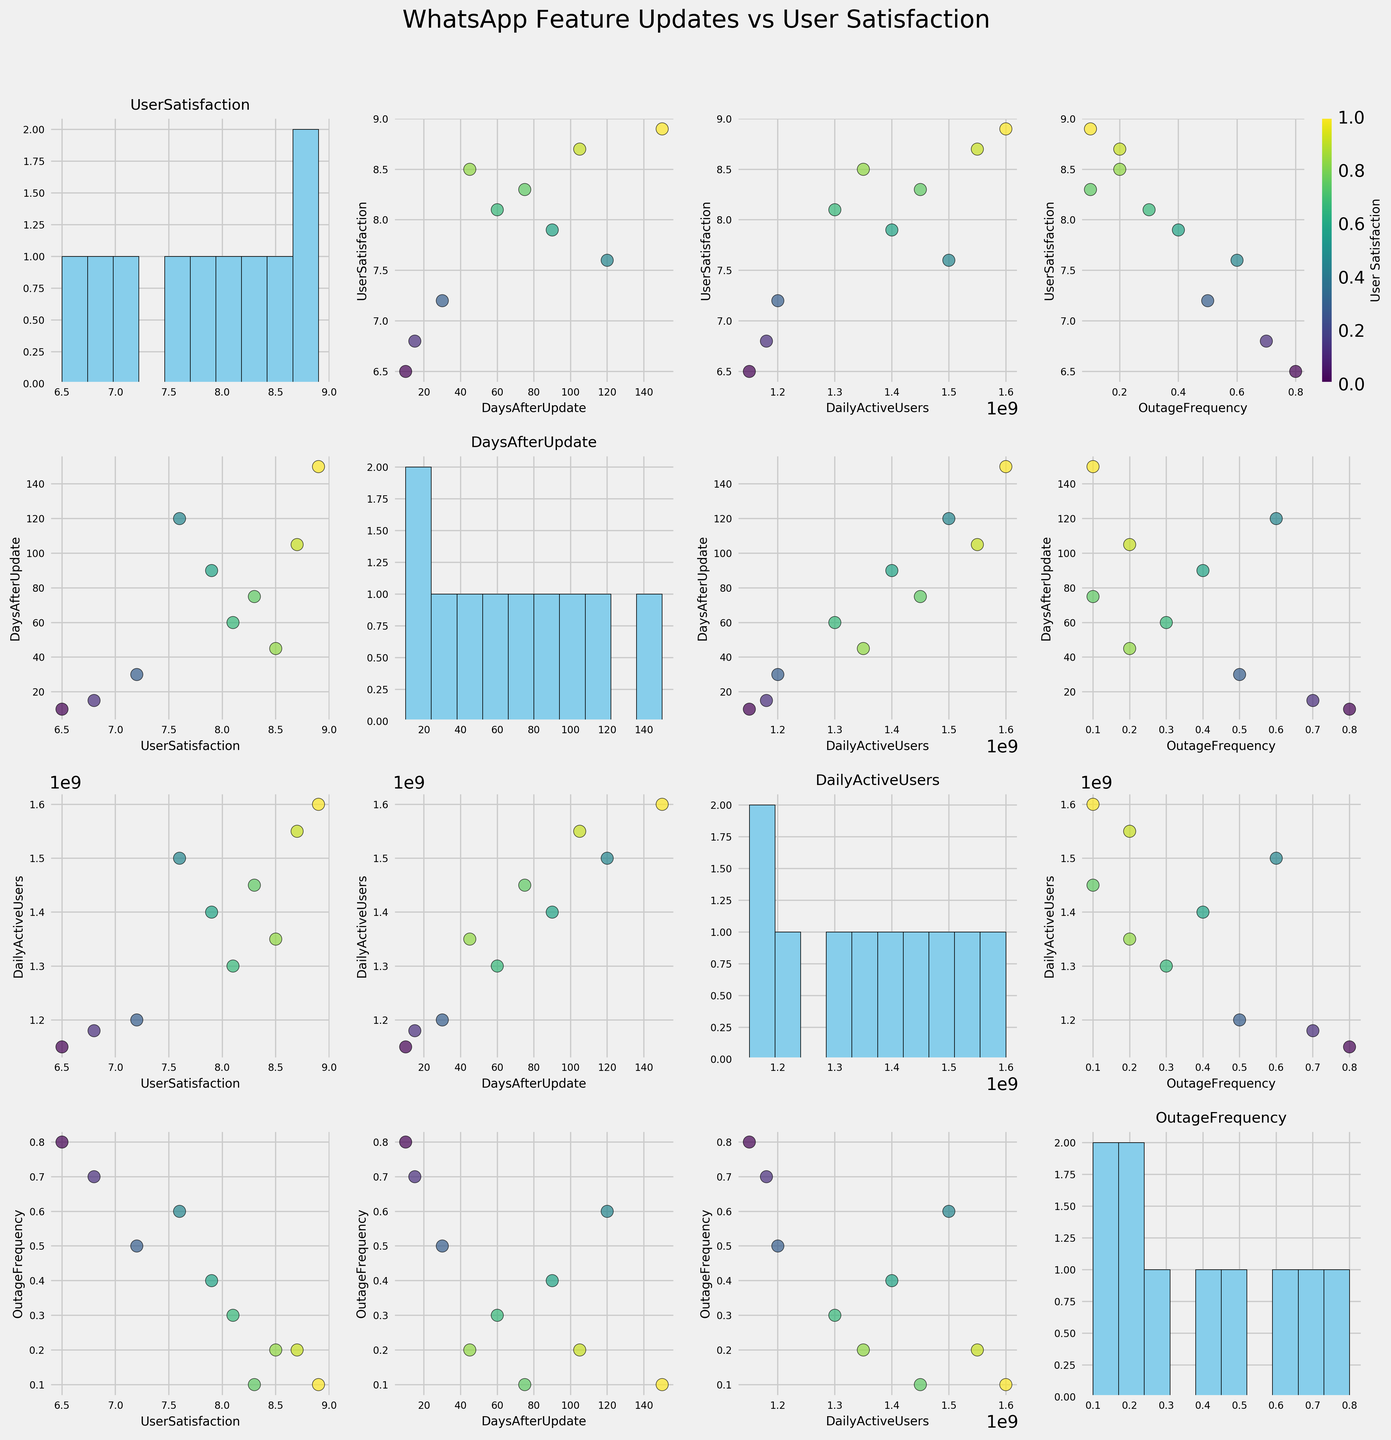How many data points are there for each scatter plot? There are 10 different WhatsApp features represented in the data, and each feature corresponds to one data point visible in the scatter plots.
Answer: 10 What is the title of the figure? The title of the figure is prominently displayed above the scatter plot matrix. It reads "WhatsApp Feature Updates vs User Satisfaction."
Answer: WhatsApp Feature Updates vs User Satisfaction Which axis title appears most frequently in the scatter plot matrix? Each unique feature name appears as both an x-axis and a y-axis label in the scatter plot matrix. Since the x-axis and y-axis titles are repeated for all subplots, each feature name appears the same number of times.
Answer: All features equally What is the primary color scheme used in the scatter plots? The scatter plots use a color scheme based on the 'viridis' colormap, which transitions from purple to yellow as the value increases.
Answer: Viridis (purple to yellow) Which feature has the highest user satisfaction rating? To answer this, look at the histogram along the diagonal for User Satisfaction. The highest bar represents the highest User Satisfaction value. "Backup Encryption" has the highest User Satisfaction rating, which is 8.9.
Answer: Backup Encryption What is the relationship between Daily Active Users and Outage Frequency? Observe the scatter plot where Daily Active Users is on the x-axis and Outage Frequency is on the y-axis. The trend shows that as Daily Active Users increase, Outage Frequency generally decreases.
Answer: Inverse relationship Which pair of features appears to have the strongest correlation in the scatter plot matrix? By examining the scatter plots for the tightest clustering around a straight line, it appears that User Satisfaction and Daily Active Users have a strong positive correlation. Scatter plots between other variables show more dispersion.
Answer: User Satisfaction and Daily Active Users How does the User Satisfaction vary with respect to Days After Update? Refer to the scatter plot with User Satisfaction on the y-axis and Days After Update on the x-axis. Points tend to show an upward trend indicating User Satisfaction tends to increase as Days After Update increases.
Answer: Increases with time Which feature update had the lowest user satisfaction rating and its corresponding outage frequency? Check the histogram for the feature with the lowest bar in User Satisfaction, which is "Communities" with a User Satisfaction of 6.5. Then, cross-reference it with its Outage Frequency in the respective scatter plot. "Communities" has an Outage Frequency of 0.8.
Answer: Communities, 0.8 